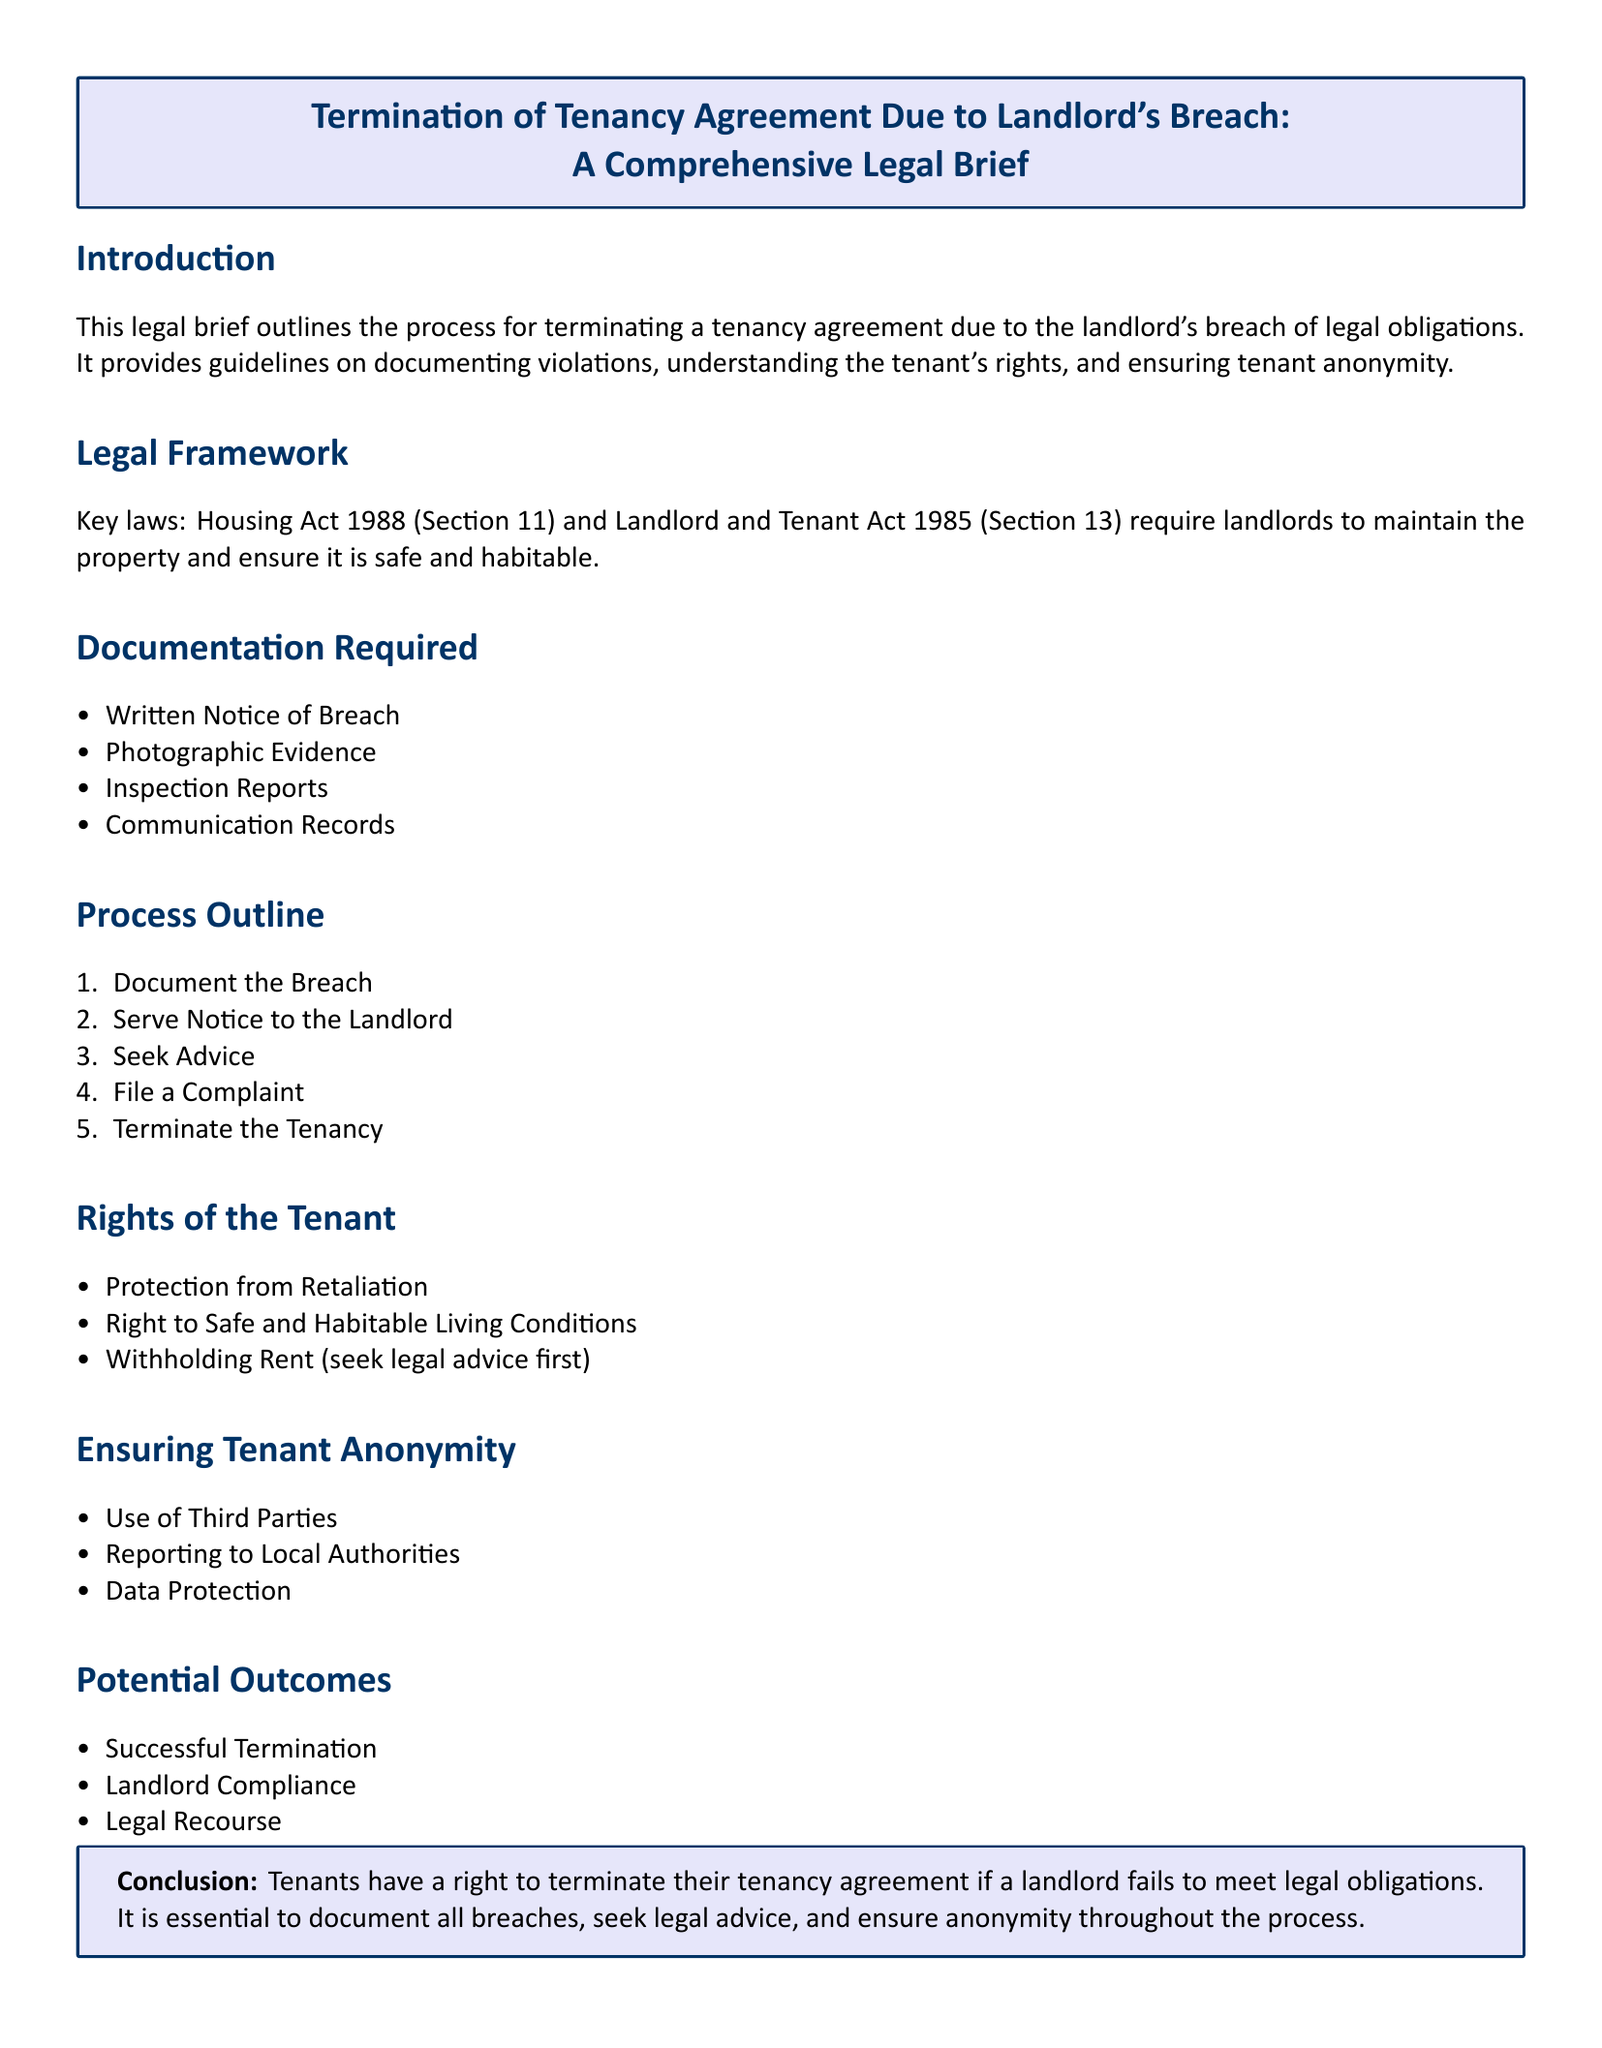What is the title of the document? The title of the document is the main heading presented at the beginning, indicating its focus.
Answer: Termination of Tenancy Agreement Due to Landlord's Breach: A Comprehensive Legal Brief Which laws are mentioned in the legal framework? The document outlines the key laws relevant to the landlord's obligations towards the tenant.
Answer: Housing Act 1988, Landlord and Tenant Act 1985 What is the first step in the process outline? The process outline provides a sequence of steps to follow when facing a landlord's breach.
Answer: Document the Breach What type of evidence is required for documentation? The document specifies what kind of evidence needs to be collected to support the claim against the landlord.
Answer: Photographic Evidence What outcome allows the landlord to avoid termination? The document discusses possible results following a tenant's action against a landlord breach, permitting landlords to correct the situation.
Answer: Landlord Compliance What is a right of the tenant outlined in the document? The document highlights specific rights that tenants possess regarding their living conditions and dealings with the landlord.
Answer: Right to Safe and Habitable Living Conditions How can a tenant ensure their anonymity? The document provides methods through which tenants can protect their identity during the process of addressing a landlord's breach.
Answer: Use of Third Parties What is the purpose of filing a complaint? The process outline indicates various steps, among which filing a complaint serves to address and escalate the issue with applicable authorities.
Answer: To address the issue formally 